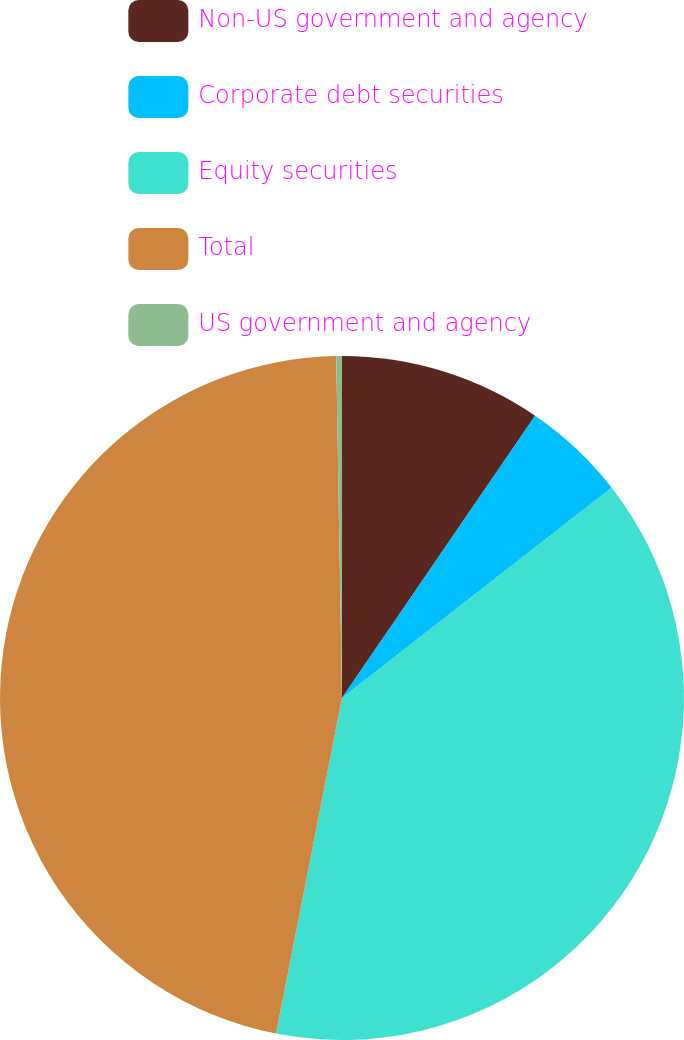Convert chart. <chart><loc_0><loc_0><loc_500><loc_500><pie_chart><fcel>Non-US government and agency<fcel>Corporate debt securities<fcel>Equity securities<fcel>Total<fcel>US government and agency<nl><fcel>9.55%<fcel>4.91%<fcel>38.63%<fcel>46.64%<fcel>0.27%<nl></chart> 